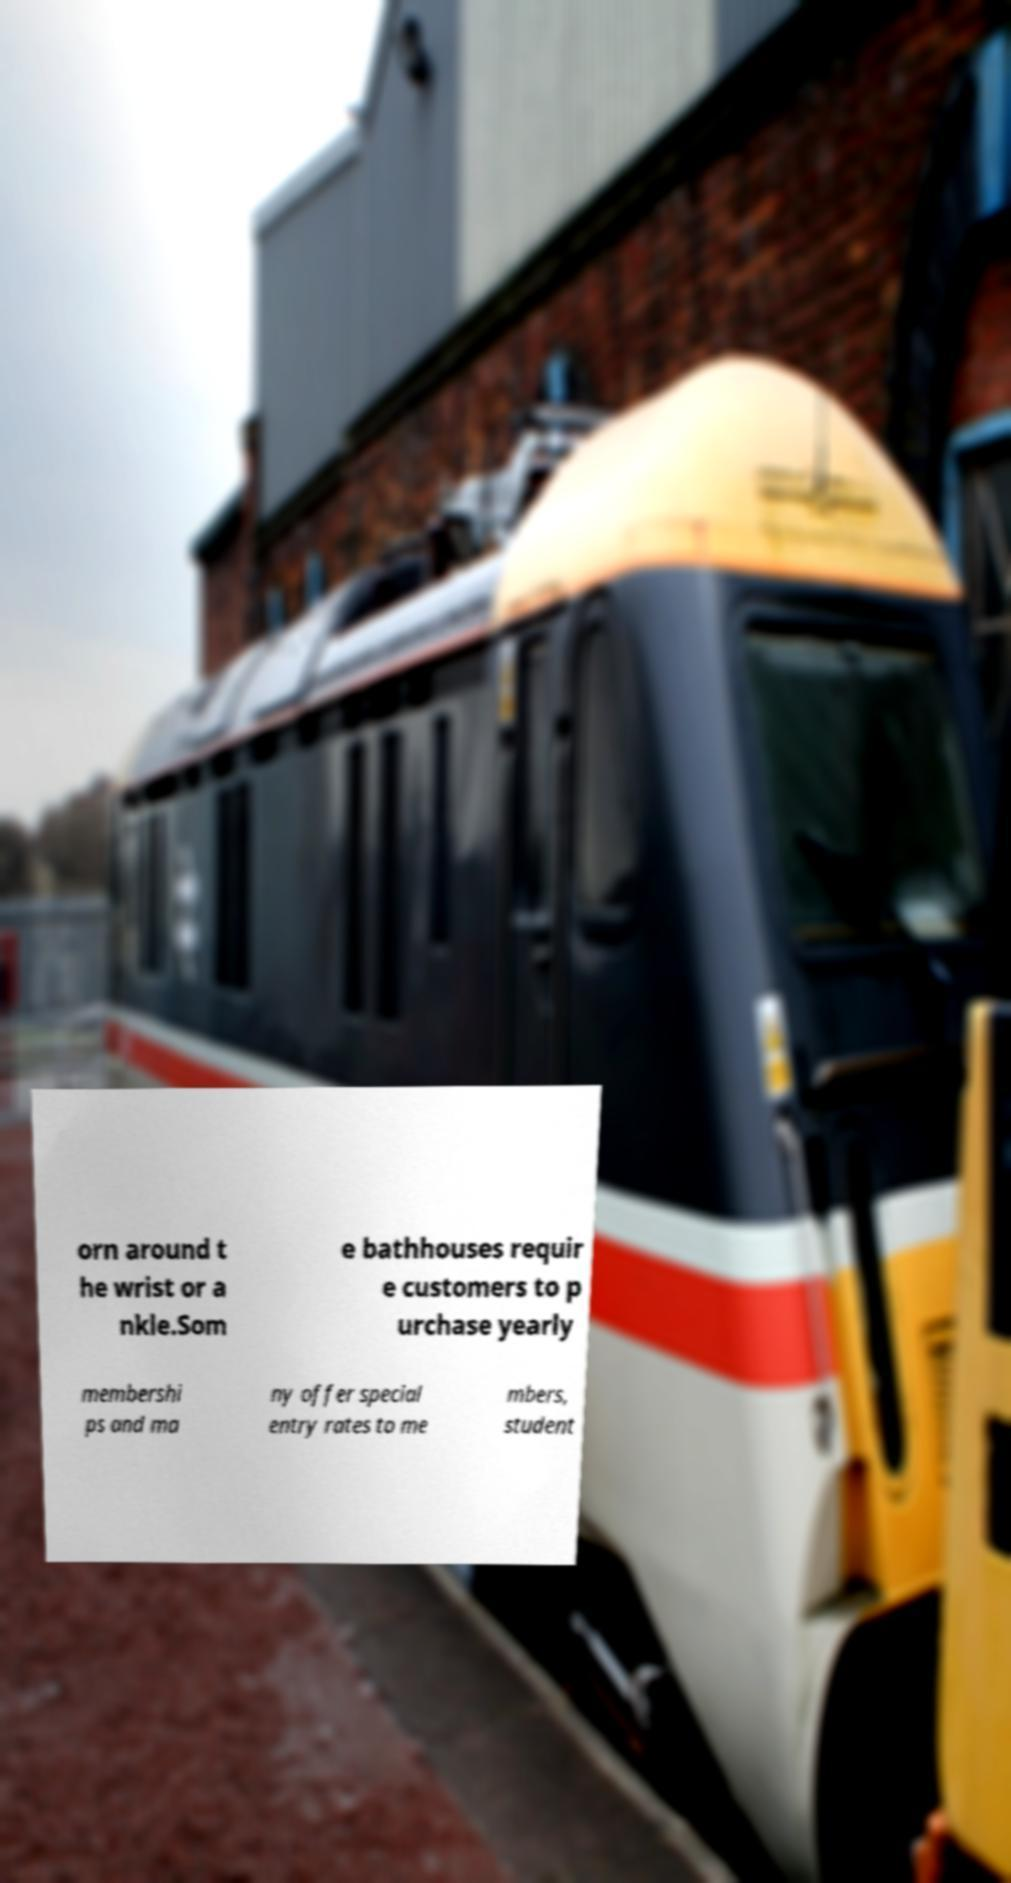Can you read and provide the text displayed in the image?This photo seems to have some interesting text. Can you extract and type it out for me? orn around t he wrist or a nkle.Som e bathhouses requir e customers to p urchase yearly membershi ps and ma ny offer special entry rates to me mbers, student 